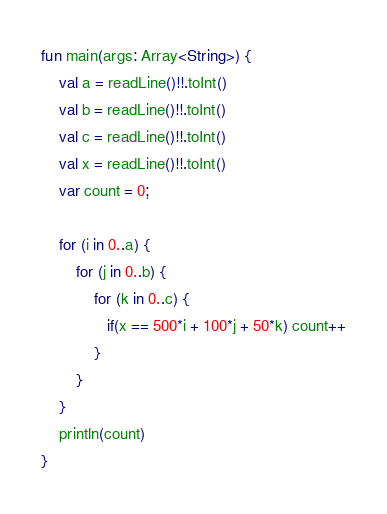Convert code to text. <code><loc_0><loc_0><loc_500><loc_500><_Kotlin_>fun main(args: Array<String>) {
    val a = readLine()!!.toInt()
    val b = readLine()!!.toInt()
    val c = readLine()!!.toInt()
    val x = readLine()!!.toInt()
    var count = 0;

    for (i in 0..a) {
        for (j in 0..b) {
            for (k in 0..c) {
               if(x == 500*i + 100*j + 50*k) count++
            }
        }
    }
    println(count)
}</code> 